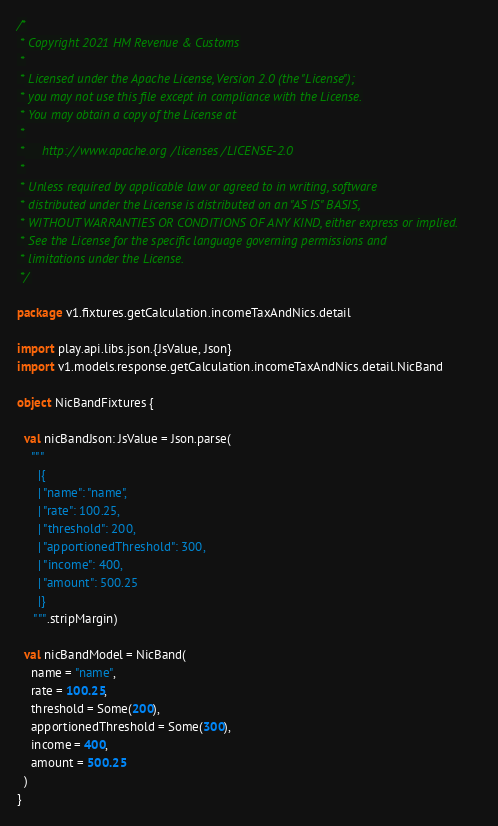<code> <loc_0><loc_0><loc_500><loc_500><_Scala_>/*
 * Copyright 2021 HM Revenue & Customs
 *
 * Licensed under the Apache License, Version 2.0 (the "License");
 * you may not use this file except in compliance with the License.
 * You may obtain a copy of the License at
 *
 *     http://www.apache.org/licenses/LICENSE-2.0
 *
 * Unless required by applicable law or agreed to in writing, software
 * distributed under the License is distributed on an "AS IS" BASIS,
 * WITHOUT WARRANTIES OR CONDITIONS OF ANY KIND, either express or implied.
 * See the License for the specific language governing permissions and
 * limitations under the License.
 */

package v1.fixtures.getCalculation.incomeTaxAndNics.detail

import play.api.libs.json.{JsValue, Json}
import v1.models.response.getCalculation.incomeTaxAndNics.detail.NicBand

object NicBandFixtures {

  val nicBandJson: JsValue = Json.parse(
    """
      |{
      |	"name": "name",
      |	"rate": 100.25,
      |	"threshold": 200,
      |	"apportionedThreshold": 300,
      |	"income": 400,
      |	"amount": 500.25
      |}
     """.stripMargin)

  val nicBandModel = NicBand(
    name = "name",
    rate = 100.25,
    threshold = Some(200),
    apportionedThreshold = Some(300),
    income = 400,
    amount = 500.25
  )
}</code> 